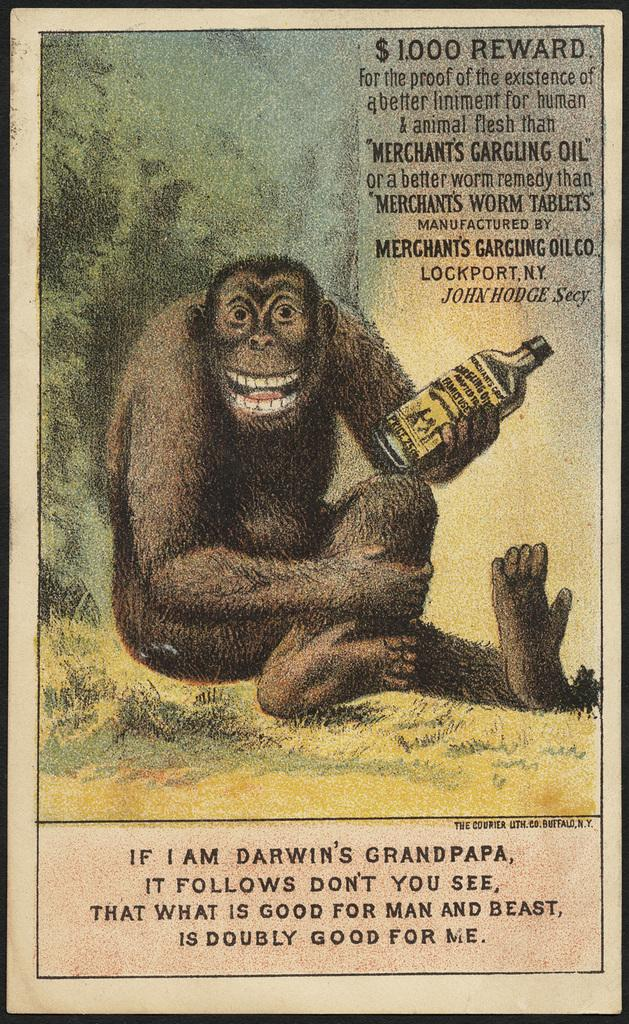What is present on the poster in the image? There is an image and text written on the poster in the image. Can you describe the image on the poster? Unfortunately, the specific image on the poster cannot be described with the information provided. What type of information is conveyed through the text on the poster? The content of the text on the poster cannot be determined with the information given. How many cattle are grazing on the clover in the image? There is no mention of cattle or clover in the image, so this question cannot be answered. 